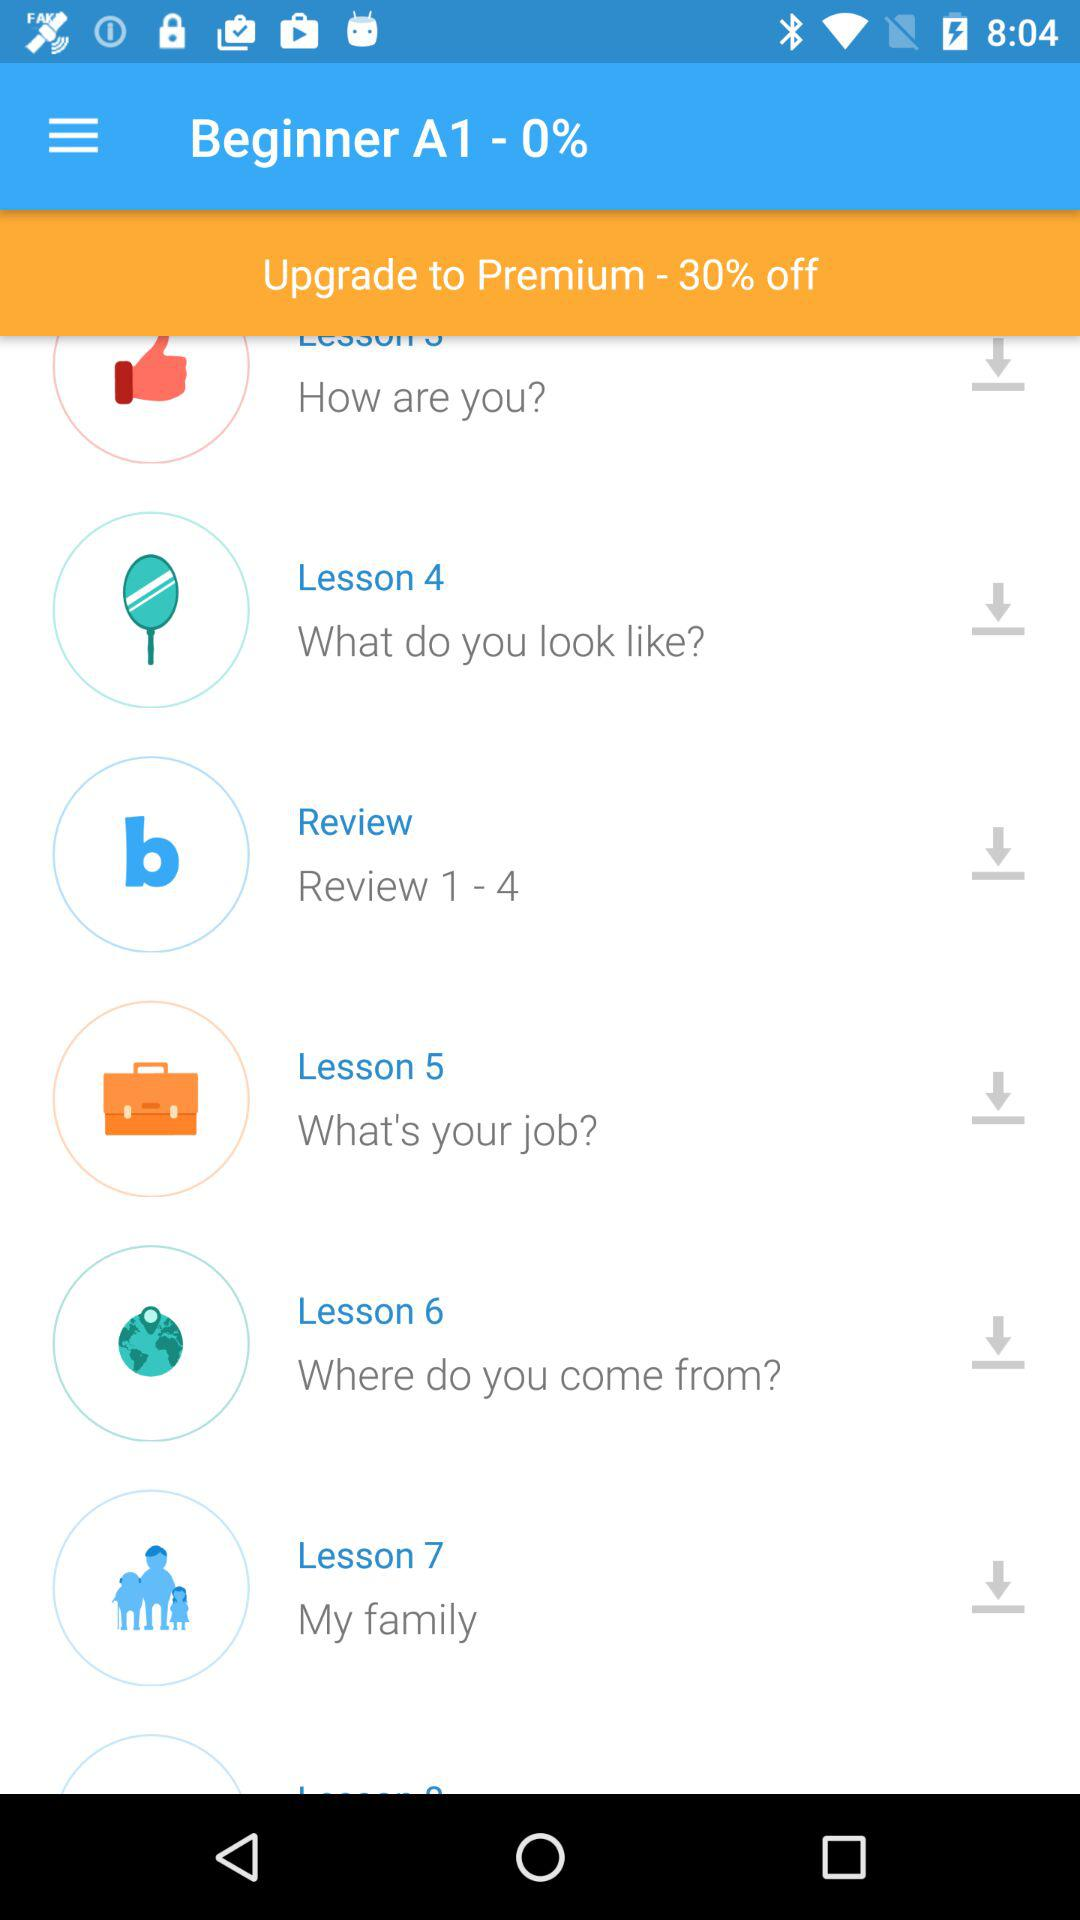What is Lesson 5 about? Lesson 5 is about "What's your job?". 